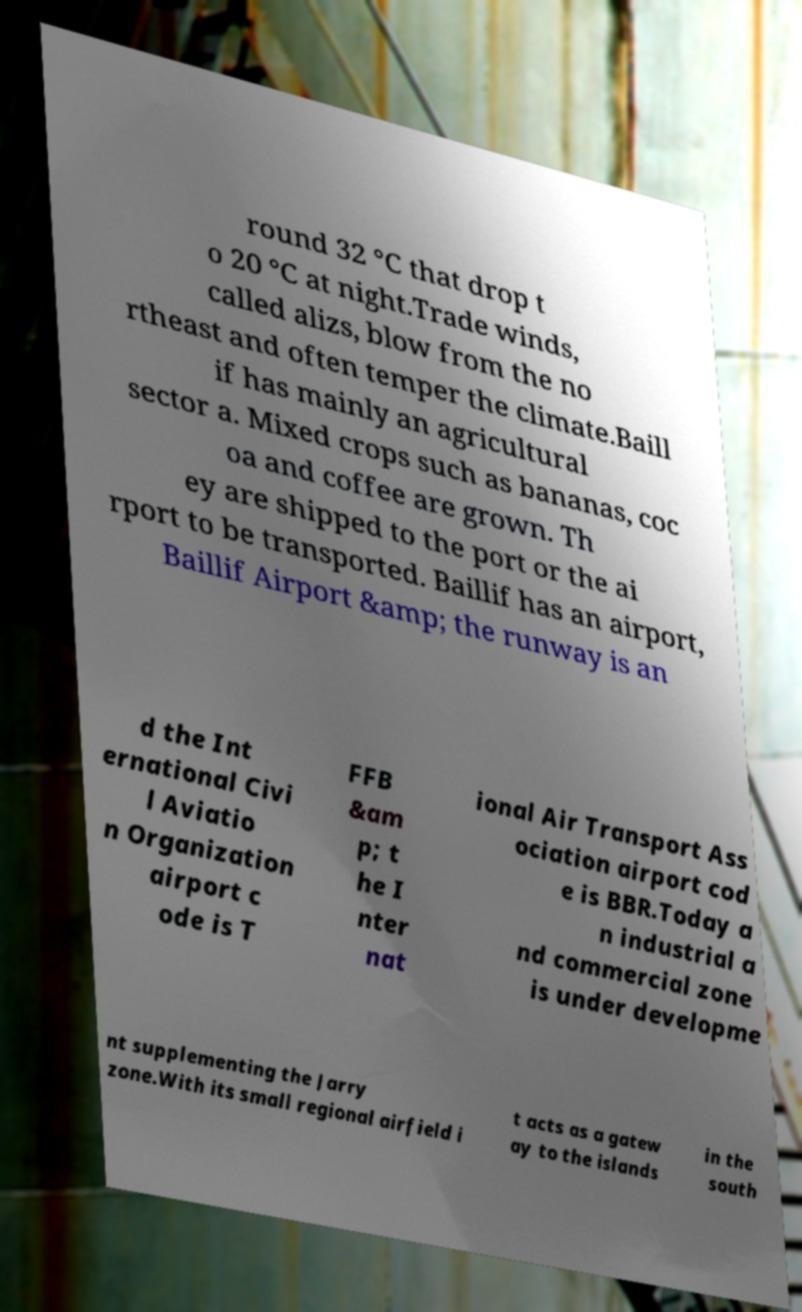I need the written content from this picture converted into text. Can you do that? round 32 °C that drop t o 20 °C at night.Trade winds, called alizs, blow from the no rtheast and often temper the climate.Baill if has mainly an agricultural sector a. Mixed crops such as bananas, coc oa and coffee are grown. Th ey are shipped to the port or the ai rport to be transported. Baillif has an airport, Baillif Airport &amp; the runway is an d the Int ernational Civi l Aviatio n Organization airport c ode is T FFB &am p; t he I nter nat ional Air Transport Ass ociation airport cod e is BBR.Today a n industrial a nd commercial zone is under developme nt supplementing the Jarry zone.With its small regional airfield i t acts as a gatew ay to the islands in the south 